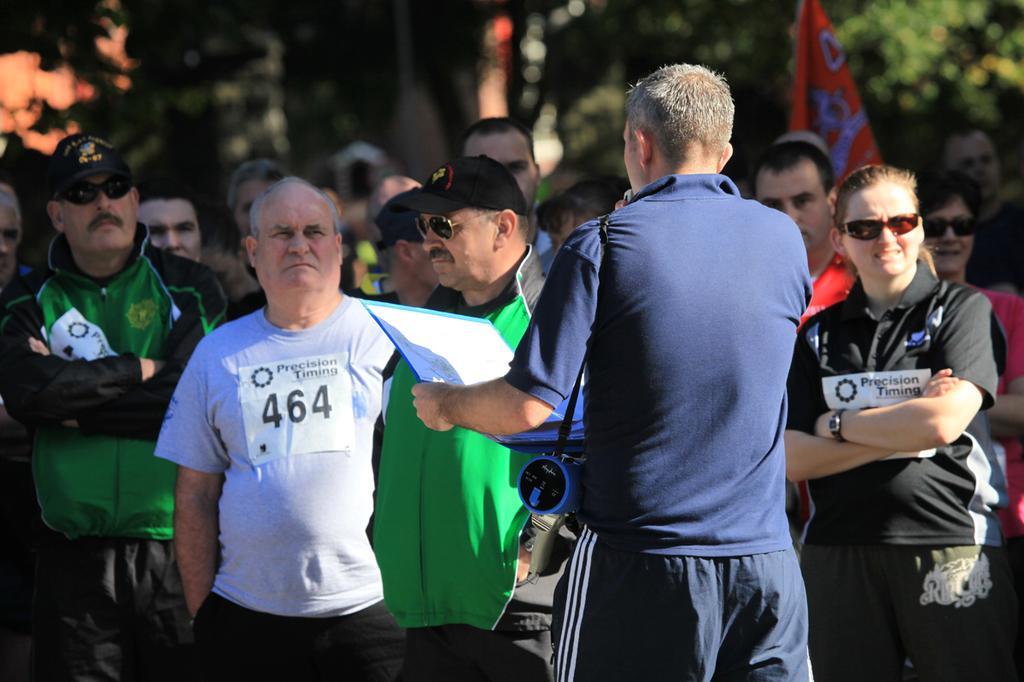Can you describe this image briefly? As we can see in the image in the front there are group of people standing. In the background there are trees and there is a flag. The man standing in the front is wearing blue color jacket and holding laptop. 